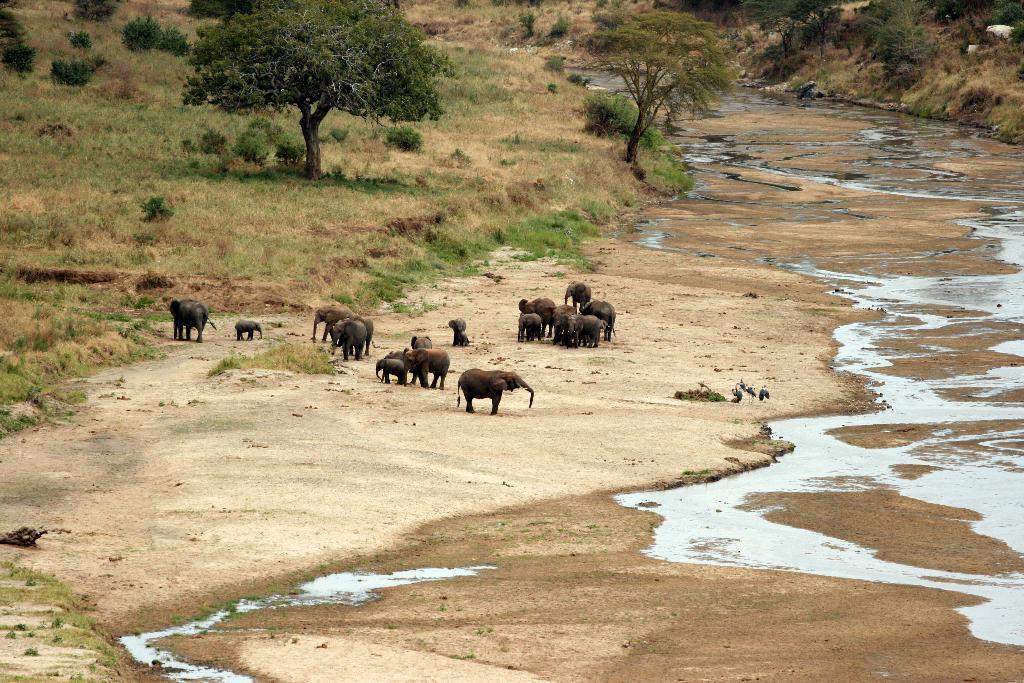In one or two sentences, can you explain what this image depicts? At the bottom, we see the soil, grass and water. In the middle, we see the elephants, calves and the birds. There are trees and the grass in the background. 